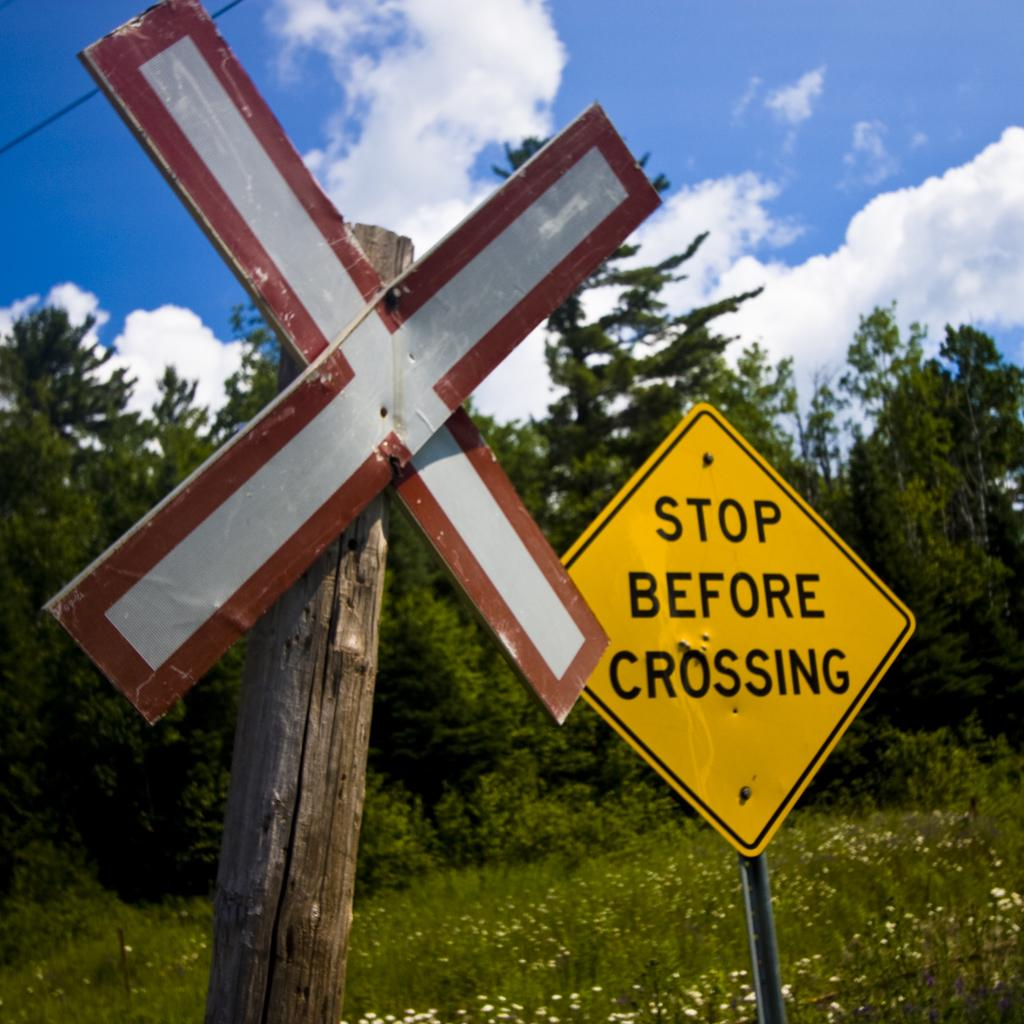<image>
Present a compact description of the photo's key features. A criss cross sign is to the left of a yellow sign that says "Stop before crossing". 